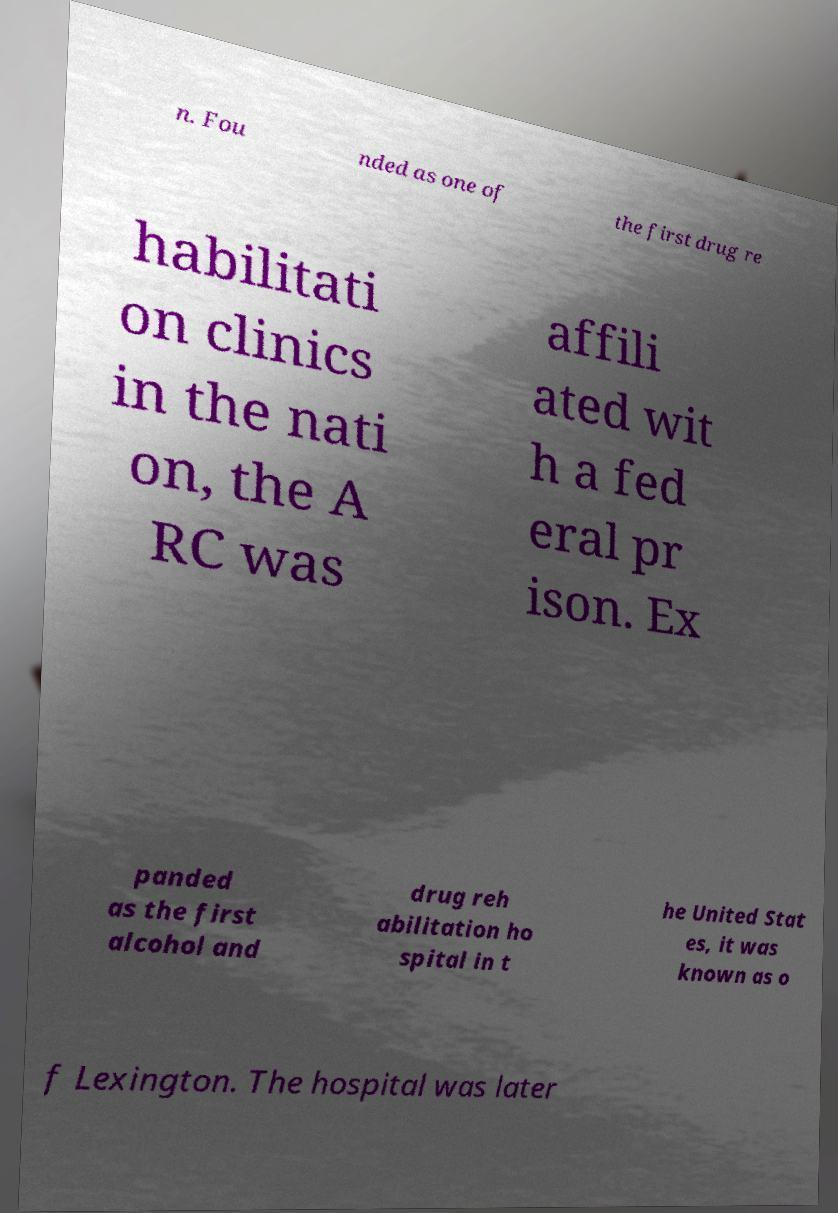Could you assist in decoding the text presented in this image and type it out clearly? n. Fou nded as one of the first drug re habilitati on clinics in the nati on, the A RC was affili ated wit h a fed eral pr ison. Ex panded as the first alcohol and drug reh abilitation ho spital in t he United Stat es, it was known as o f Lexington. The hospital was later 